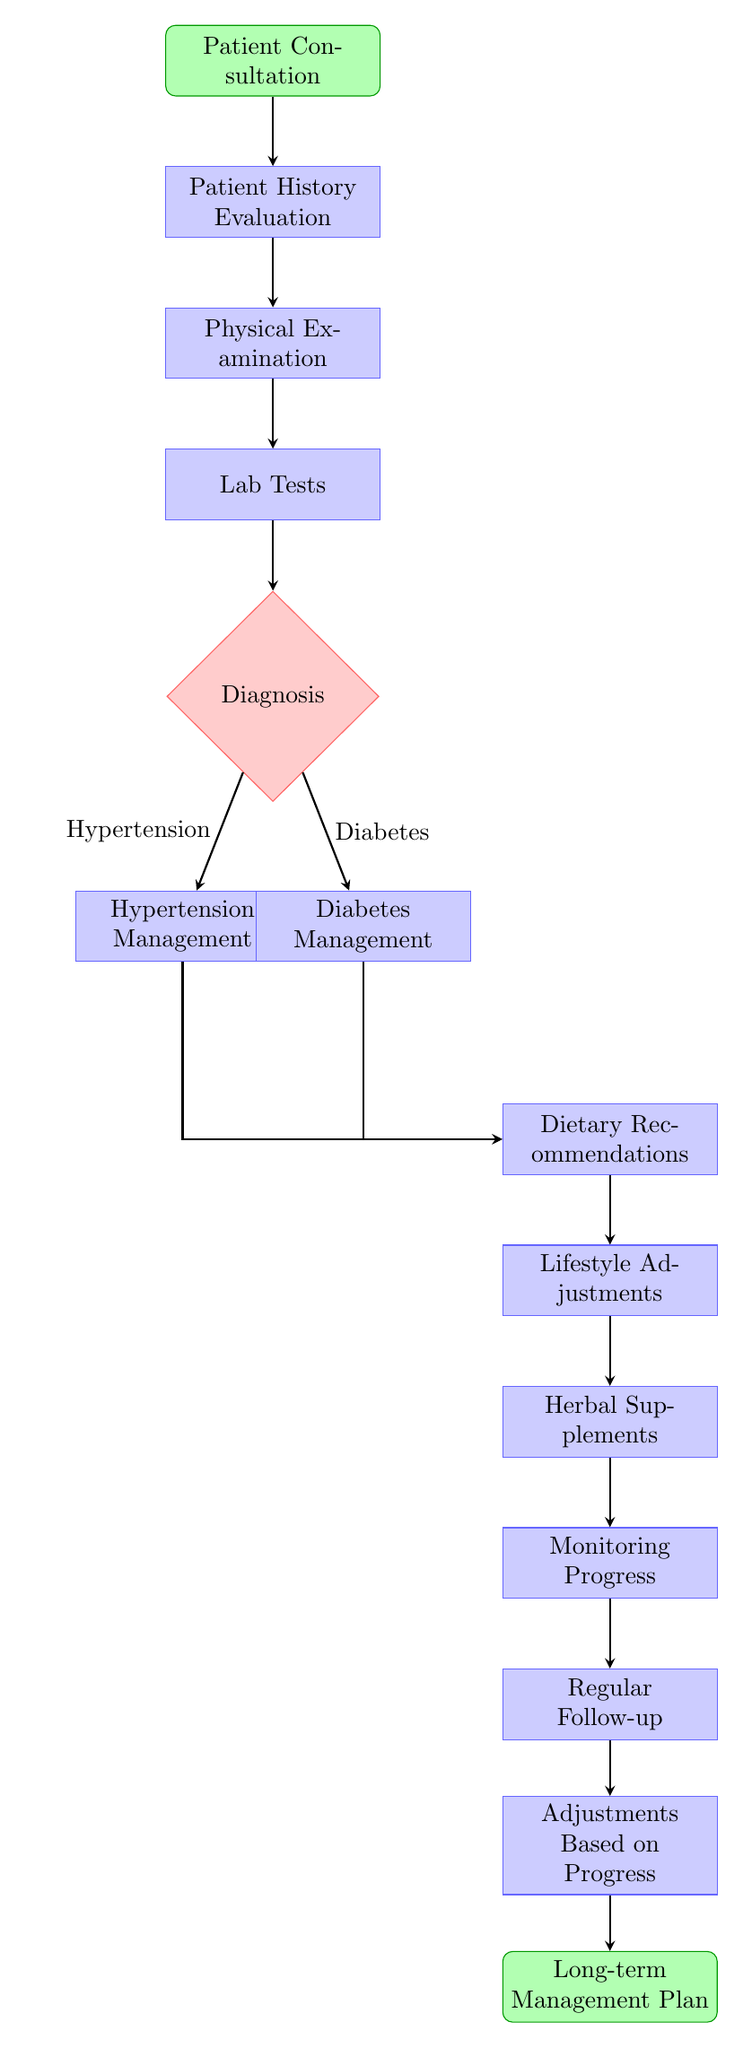What is the first step in the management of chronic diseases? The first step in the flowchart is "Patient Consultation," which is the initial contact with the patient to begin the management process.
Answer: Patient Consultation How many main management categories are there after diagnosis? After the diagnosis node, there are two main management branches: "Hypertension Management" and "Diabetes Management." Thus, the number of categories is two.
Answer: 2 What is the last step before establishing a long-term management plan? The last step before reaching the "Long-term Management Plan" is "Adjustments Based on Progress," which indicates that treatment may be adjusted according to the patient's progress.
Answer: Adjustments Based on Progress What follows the "Lifestyle Adjustments" step in the flowchart? The step that follows "Lifestyle Adjustments" is "Herbal Supplements," which emphasizes the incorporation of herbal remedies after lifestyle changes are made.
Answer: Herbal Supplements What decision is made after the lab tests? After the lab tests, a "Diagnosis" is made, determining whether the patient has hypertension or diabetes, which directs subsequent management.
Answer: Diagnosis If the patient is diagnosed with hypertension, what is the next step in the flow? If the patient is diagnosed with hypertension, the next step is "Hypertension Management," which focuses on specific protocols for managing high blood pressure.
Answer: Hypertension Management What is the purpose of the "Monitoring Progress" step? The "Monitoring Progress" step serves to evaluate the effectiveness of the treatment plan and make necessary adjustments based on how well the patient is responding to the interventions.
Answer: Evaluate effectiveness How many arrows are pointing to the "Dietary Recommendations" step? There are two arrows pointing to the "Dietary Recommendations" step, one from "Hypertension Management" and the other from "Diabetes Management," indicating that dietary advice is relevant for both conditions.
Answer: 2 What type of diagram is illustrated? The illustrated diagram is a flowchart, which is specifically used to depict the sequential steps involved in managing chronic diseases with naturopathic methods.
Answer: Flowchart 